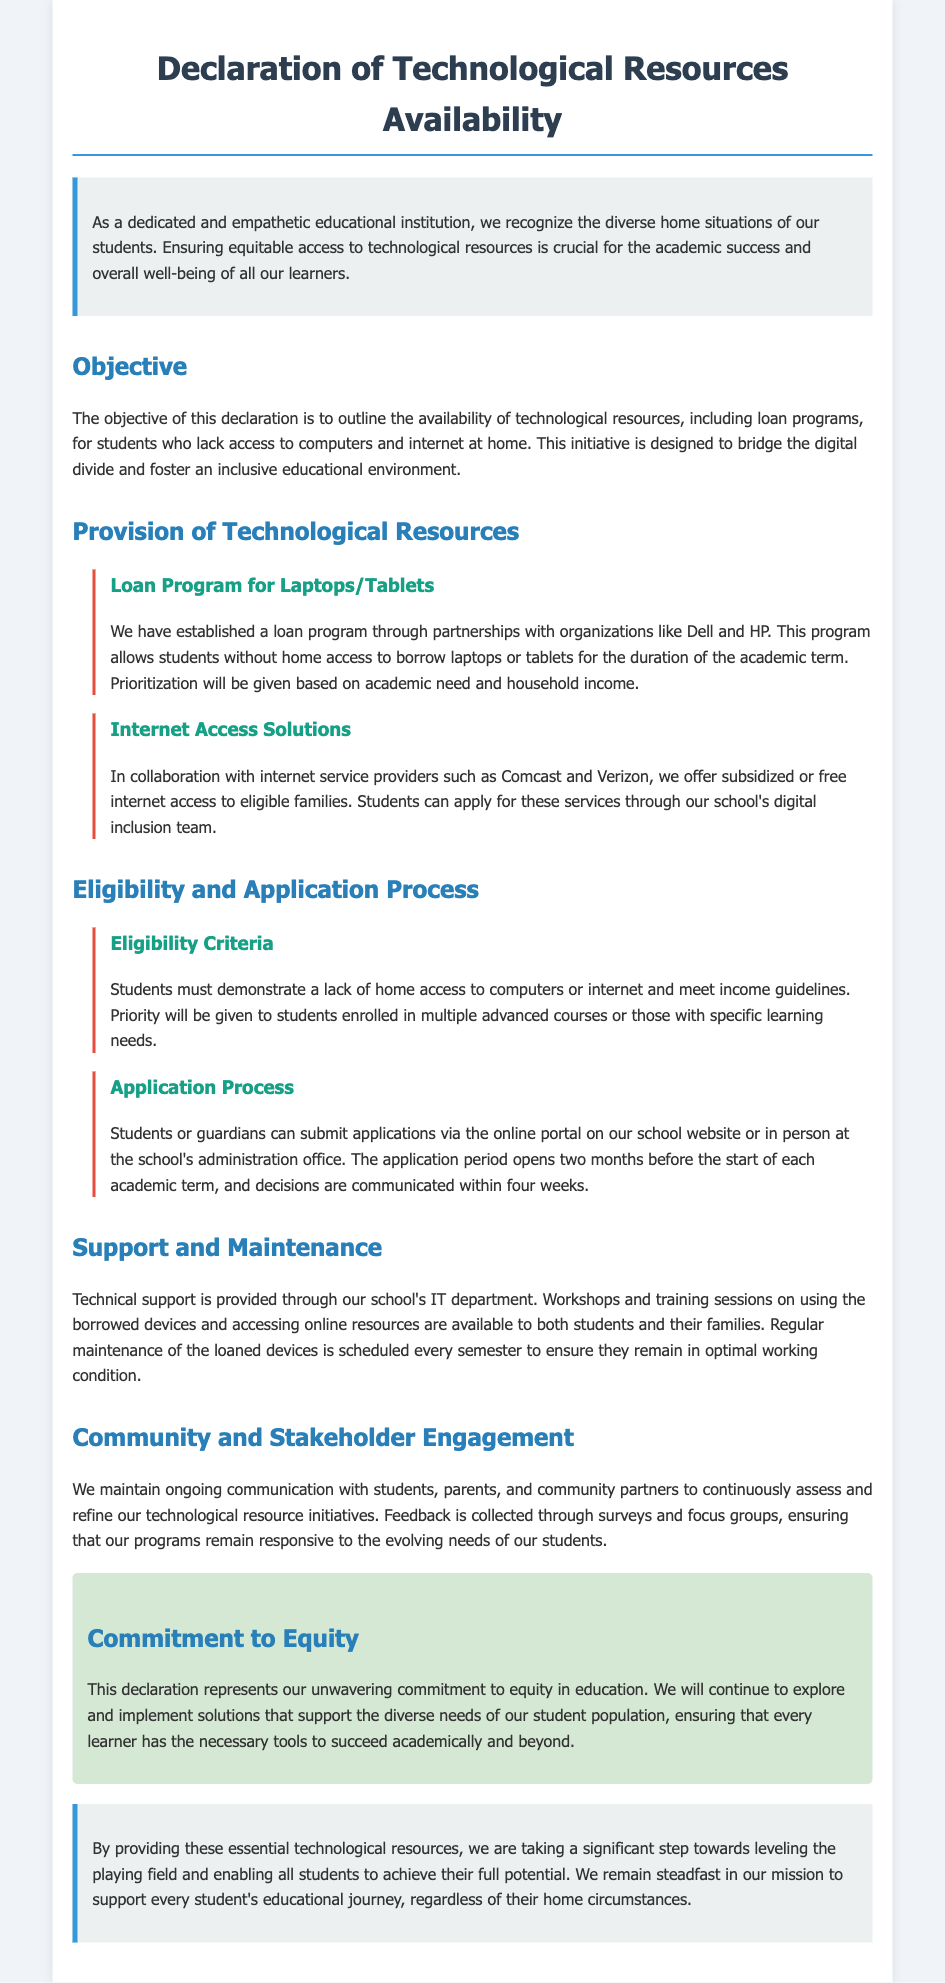What is the title of the document? The title is presented at the top of the document as the heading.
Answer: Declaration of Technological Resources Availability What organization is partnered with for the loan program? The document mentions specific partnerships established for the loan program.
Answer: Dell and HP What kind of support is provided through the IT department? The section details the type of assistance provided to students regarding technology.
Answer: Technical support What is the opening period for applications? The document specifies when students can begin applying for the loan program.
Answer: Two months before the start of each academic term How often is maintenance scheduled for the loaned devices? The document states the frequency of maintenance for the devices in a specific section.
Answer: Every semester What is the objective of this declaration? The objective is clearly outlined in the designated section of the document.
Answer: To outline the availability of technological resources Which two internet service providers are mentioned? The document specifies certain collaborations for internet solutions.
Answer: Comcast and Verizon How are priority decisions made for the loan program? The document explains the criteria for prioritizing applicants in the loan program.
Answer: Based on academic need and household income 